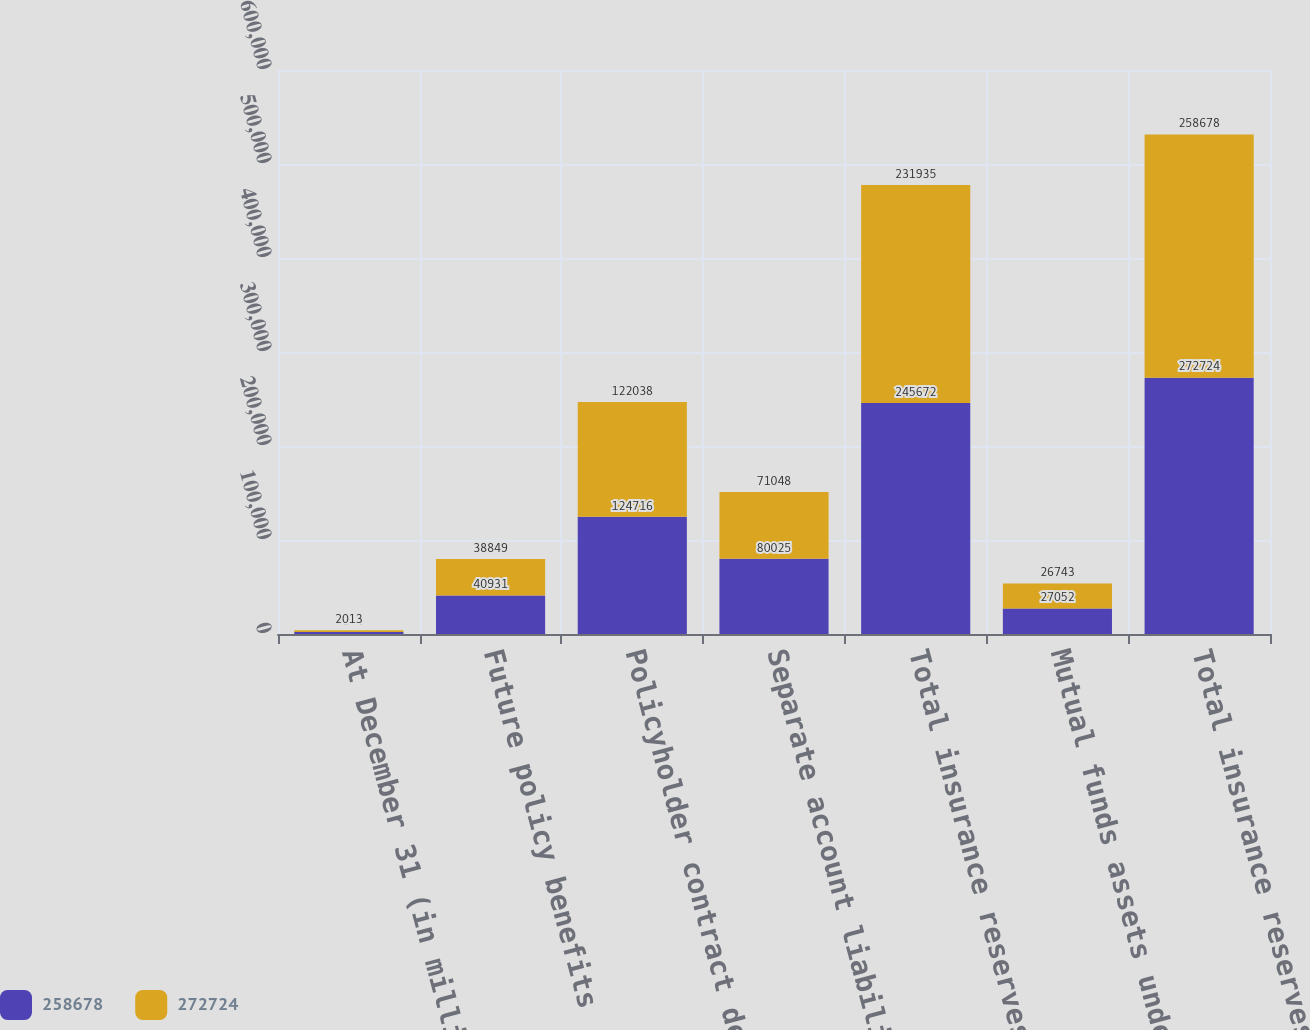<chart> <loc_0><loc_0><loc_500><loc_500><stacked_bar_chart><ecel><fcel>At December 31 (in millions)<fcel>Future policy benefits<fcel>Policyholder contract deposits<fcel>Separate account liabilities<fcel>Total insurance reserves<fcel>Mutual funds assets under<fcel>Total insurance reserves and<nl><fcel>258678<fcel>2014<fcel>40931<fcel>124716<fcel>80025<fcel>245672<fcel>27052<fcel>272724<nl><fcel>272724<fcel>2013<fcel>38849<fcel>122038<fcel>71048<fcel>231935<fcel>26743<fcel>258678<nl></chart> 